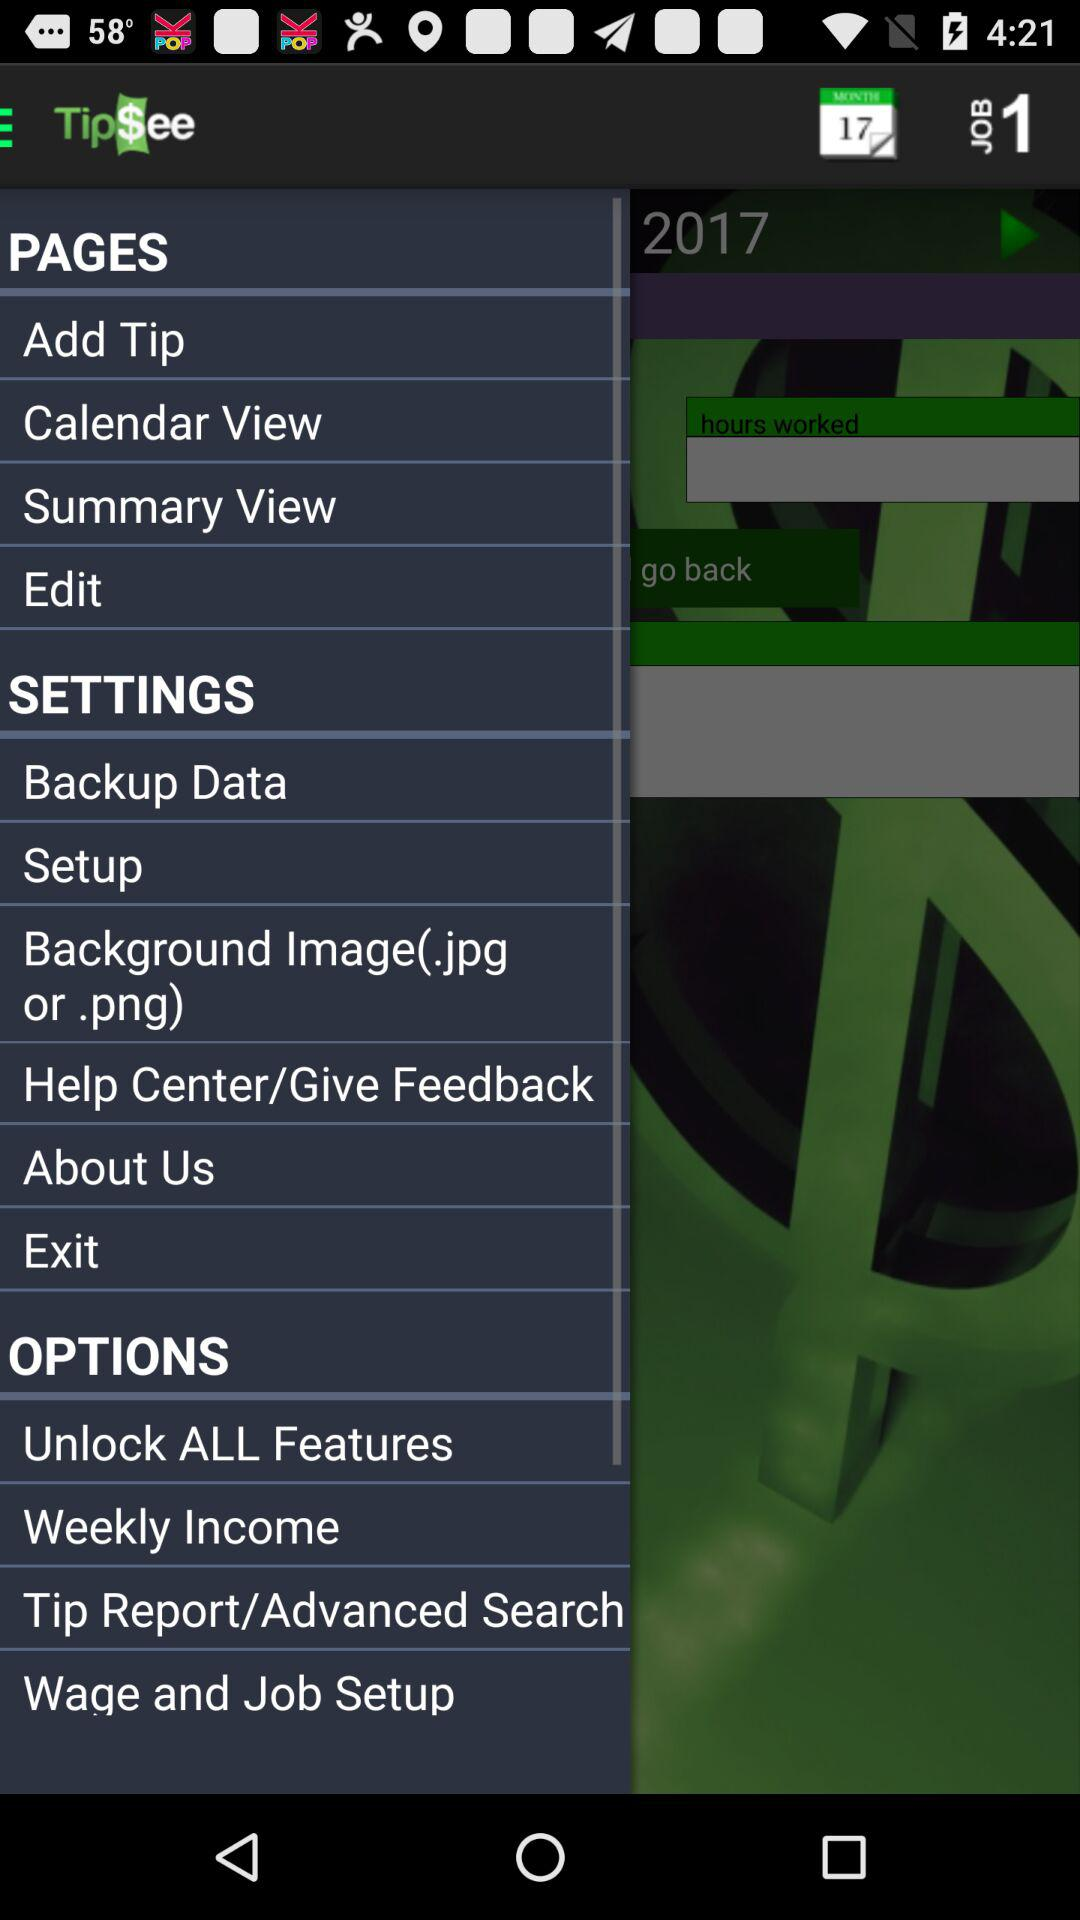What is the name of the application? The name of the application is "TipSee". 